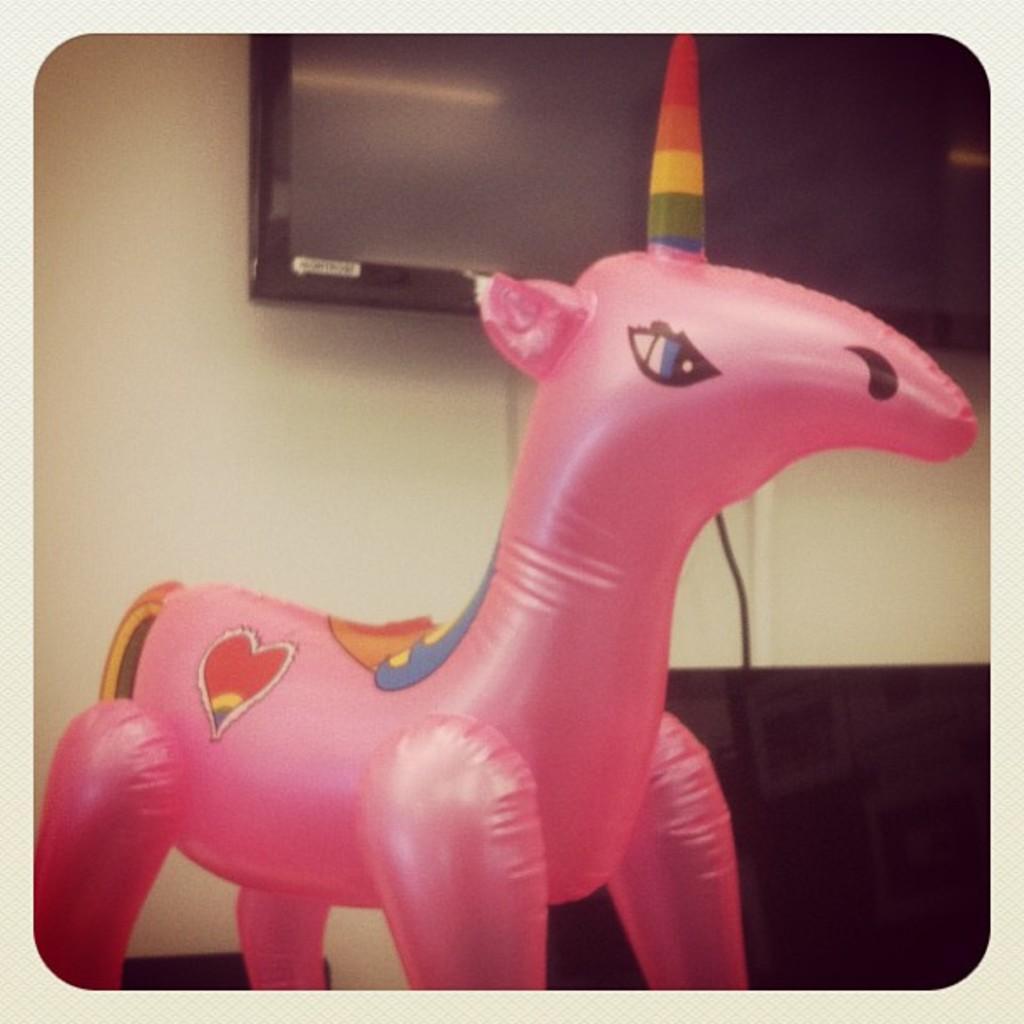In one or two sentences, can you explain what this image depicts? It looks like an edited image, we can see there is an inflatable unicorn. Behind the inflatable unicorn there's a wall with a television and a cable. 